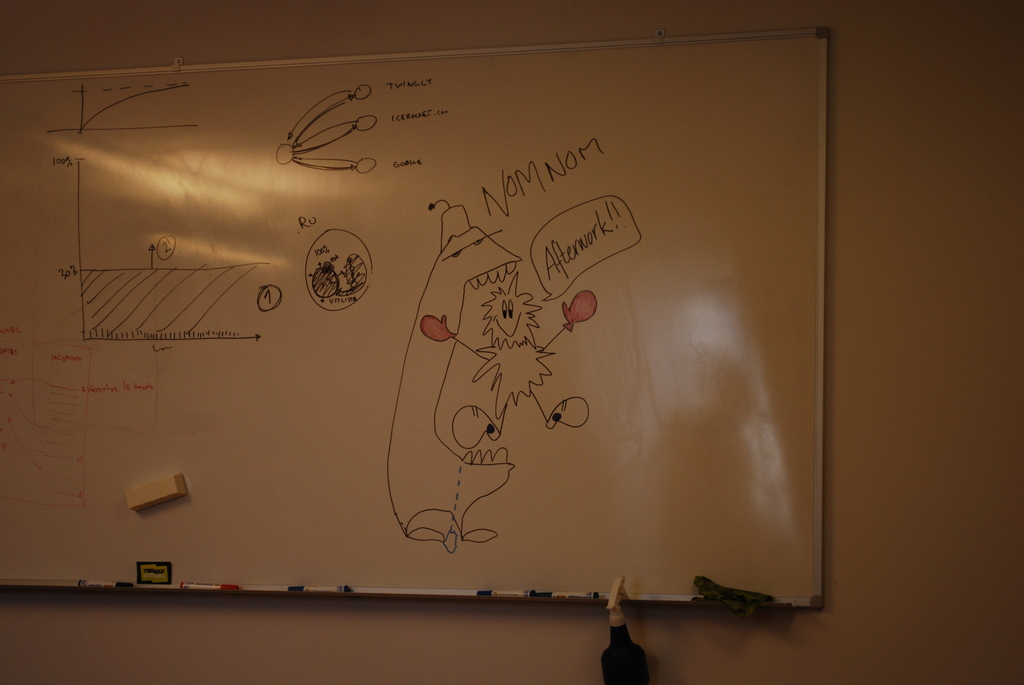Provide a one-sentence caption for the provided image. The image shows a whiteboard filled with a mix of humorous and technical drawings and notes, including a large cartoon-like figure saying 'Afterwork!' with 'NOM NOM' written inside a speech balloon, alongside various graphs and scientific data. 